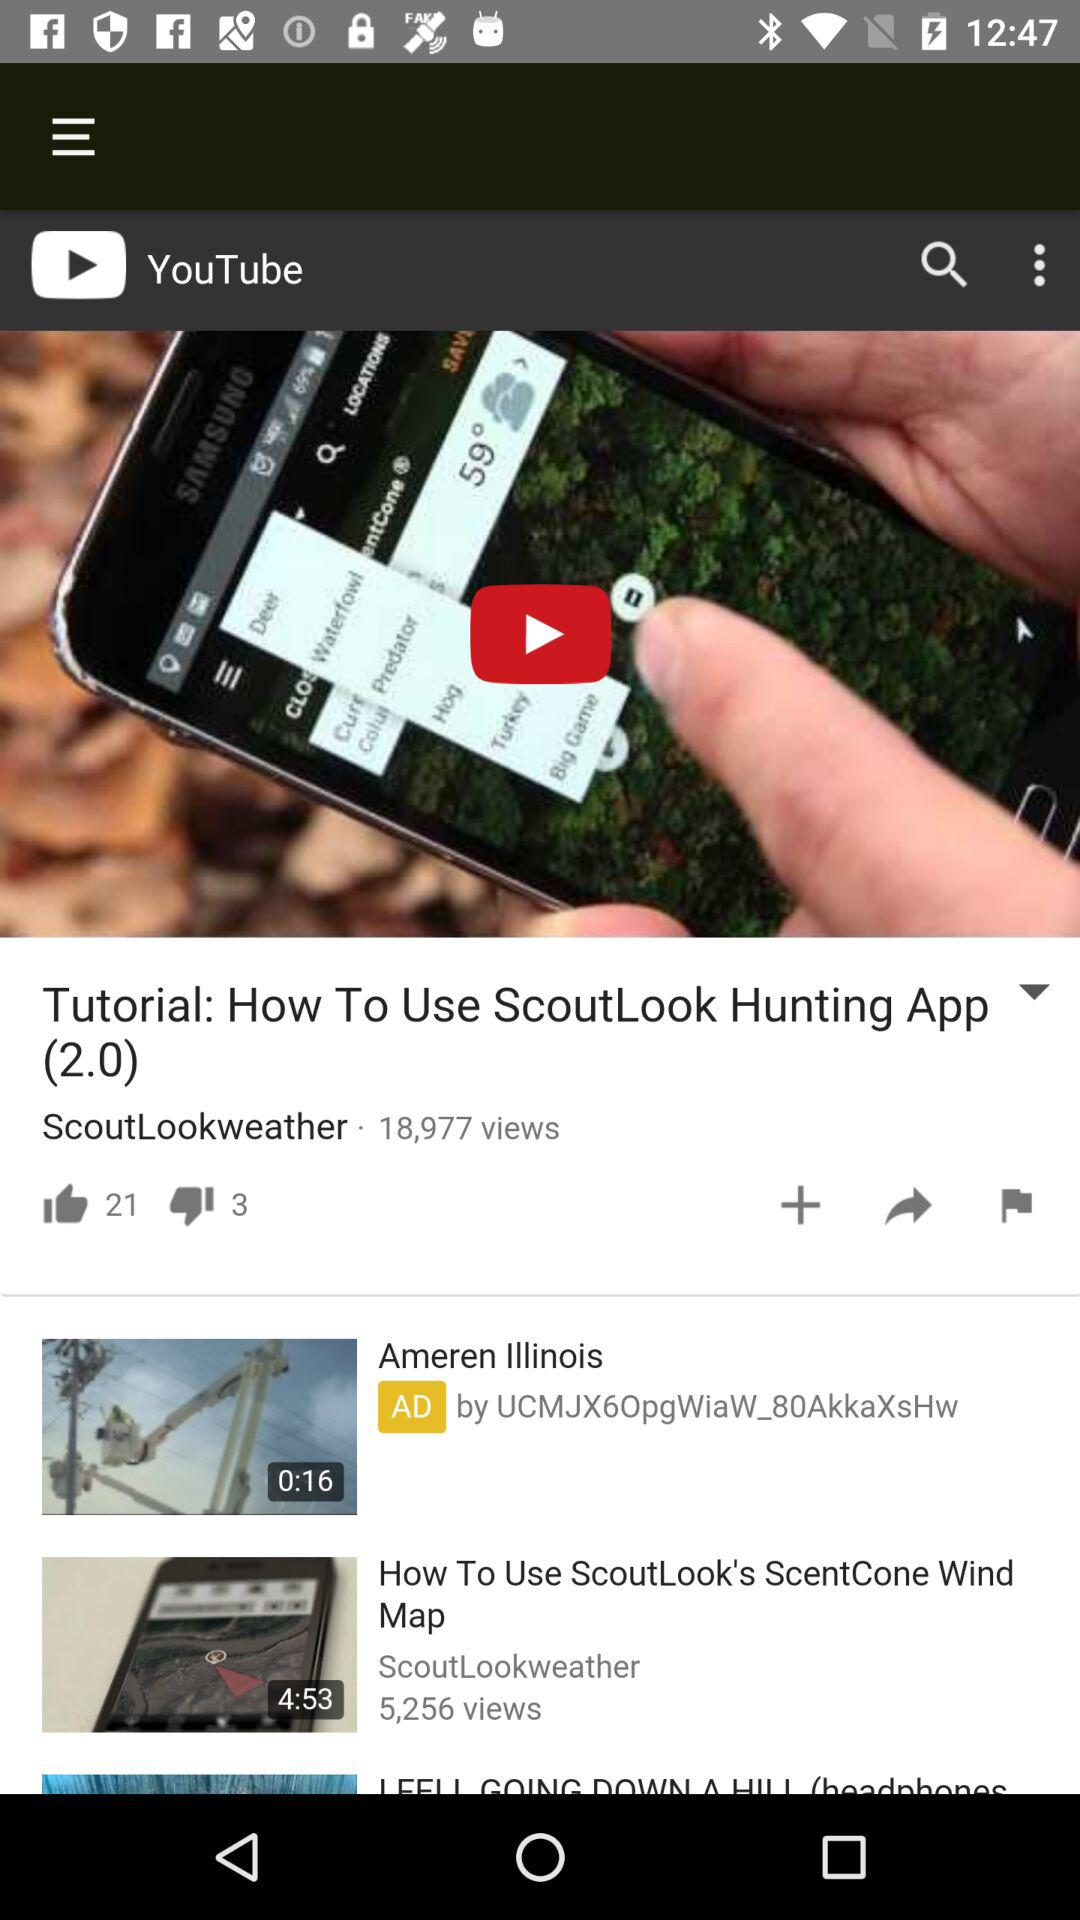What is the time duration of the video "How To Use ScoutLook's ScentCone Wind Map"? The time duration of the video is 4 minutes 53 seconds. 